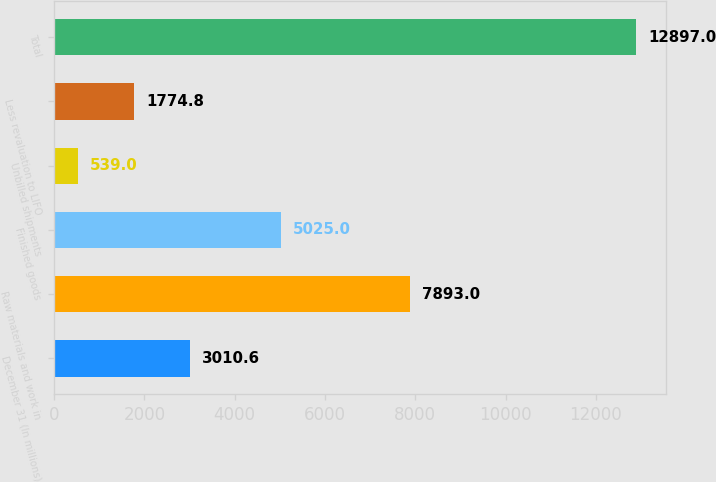Convert chart to OTSL. <chart><loc_0><loc_0><loc_500><loc_500><bar_chart><fcel>December 31 (In millions)<fcel>Raw materials and work in<fcel>Finished goods<fcel>Unbilled shipments<fcel>Less revaluation to LIFO<fcel>Total<nl><fcel>3010.6<fcel>7893<fcel>5025<fcel>539<fcel>1774.8<fcel>12897<nl></chart> 